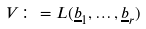<formula> <loc_0><loc_0><loc_500><loc_500>V \colon = L ( \underline { b } _ { 1 } , \dots , \underline { b } _ { r } )</formula> 